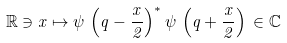Convert formula to latex. <formula><loc_0><loc_0><loc_500><loc_500>\mathbb { R } \ni x \mapsto \psi \, \left ( q - \frac { x } { 2 } \right ) ^ { * } \psi \, \left ( q + \frac { x } { 2 } \right ) \, \in \mathbb { C }</formula> 